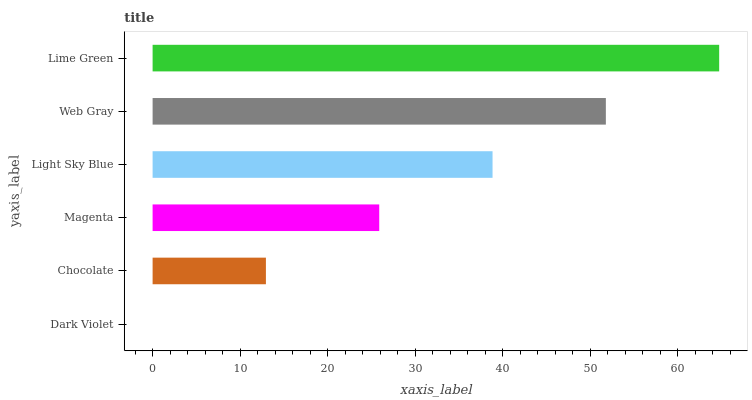Is Dark Violet the minimum?
Answer yes or no. Yes. Is Lime Green the maximum?
Answer yes or no. Yes. Is Chocolate the minimum?
Answer yes or no. No. Is Chocolate the maximum?
Answer yes or no. No. Is Chocolate greater than Dark Violet?
Answer yes or no. Yes. Is Dark Violet less than Chocolate?
Answer yes or no. Yes. Is Dark Violet greater than Chocolate?
Answer yes or no. No. Is Chocolate less than Dark Violet?
Answer yes or no. No. Is Light Sky Blue the high median?
Answer yes or no. Yes. Is Magenta the low median?
Answer yes or no. Yes. Is Chocolate the high median?
Answer yes or no. No. Is Lime Green the low median?
Answer yes or no. No. 